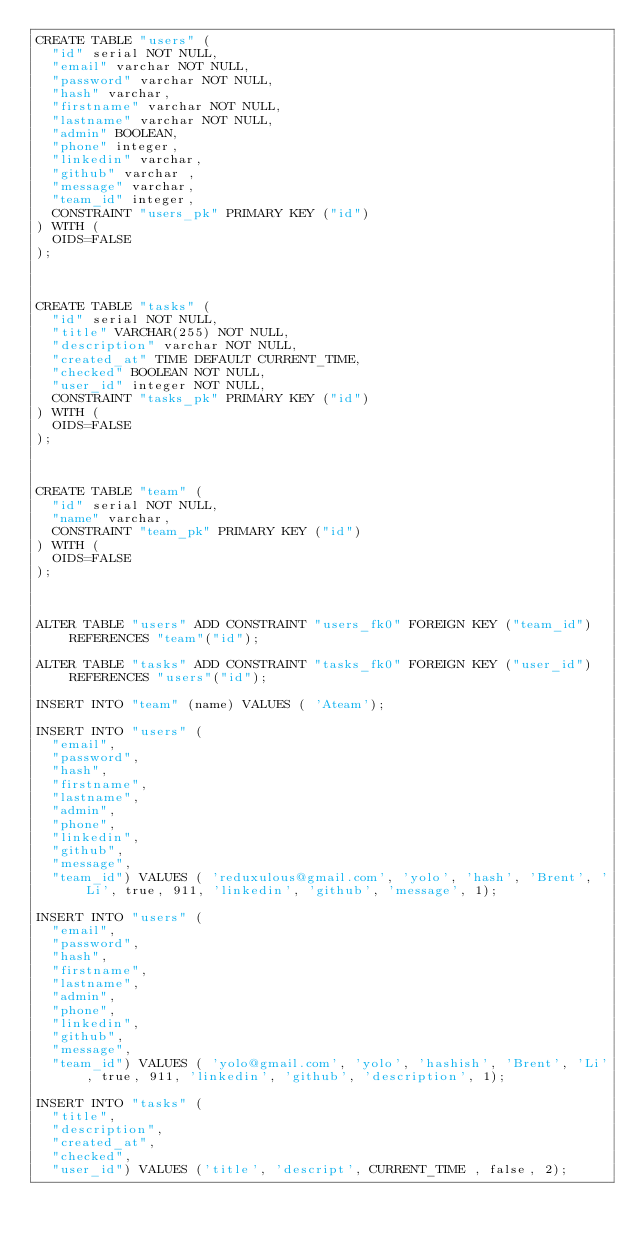Convert code to text. <code><loc_0><loc_0><loc_500><loc_500><_SQL_>CREATE TABLE "users" (
	"id" serial NOT NULL,
	"email" varchar NOT NULL,
	"password" varchar NOT NULL,
	"hash" varchar,
	"firstname" varchar NOT NULL,
	"lastname" varchar NOT NULL,
	"admin" BOOLEAN,
	"phone" integer,
	"linkedin" varchar, 
	"github" varchar ,
	"message" varchar,
	"team_id" integer,
	CONSTRAINT "users_pk" PRIMARY KEY ("id")
) WITH (
  OIDS=FALSE
);



CREATE TABLE "tasks" (
	"id" serial NOT NULL,
	"title" VARCHAR(255) NOT NULL,
	"description" varchar NOT NULL,
	"created_at" TIME DEFAULT CURRENT_TIME,
	"checked" BOOLEAN NOT NULL,
	"user_id" integer NOT NULL,
	CONSTRAINT "tasks_pk" PRIMARY KEY ("id")
) WITH (
  OIDS=FALSE
);



CREATE TABLE "team" (
	"id" serial NOT NULL,
	"name" varchar,
	CONSTRAINT "team_pk" PRIMARY KEY ("id")
) WITH (
  OIDS=FALSE
);



ALTER TABLE "users" ADD CONSTRAINT "users_fk0" FOREIGN KEY ("team_id") REFERENCES "team"("id");

ALTER TABLE "tasks" ADD CONSTRAINT "tasks_fk0" FOREIGN KEY ("user_id") REFERENCES "users"("id");

INSERT INTO "team" (name) VALUES ( 'Ateam');

INSERT INTO "users" (
	"email",
	"password",
	"hash",
	"firstname",
	"lastname",
	"admin",
	"phone",
	"linkedin", 
	"github",
	"message",
	"team_id") VALUES ( 'reduxulous@gmail.com', 'yolo', 'hash', 'Brent', 'Li', true, 911, 'linkedin', 'github', 'message', 1);

INSERT INTO "users" (
	"email",
	"password",
	"hash",
	"firstname",
	"lastname",
	"admin",
	"phone",
	"linkedin", 
	"github",
	"message",
	"team_id") VALUES ( 'yolo@gmail.com', 'yolo', 'hashish', 'Brent', 'Li', true, 911, 'linkedin', 'github', 'description', 1);

INSERT INTO "tasks" (
	"title",
	"description",
	"created_at",
	"checked",
	"user_id") VALUES ('title', 'descript', CURRENT_TIME , false, 2);
</code> 